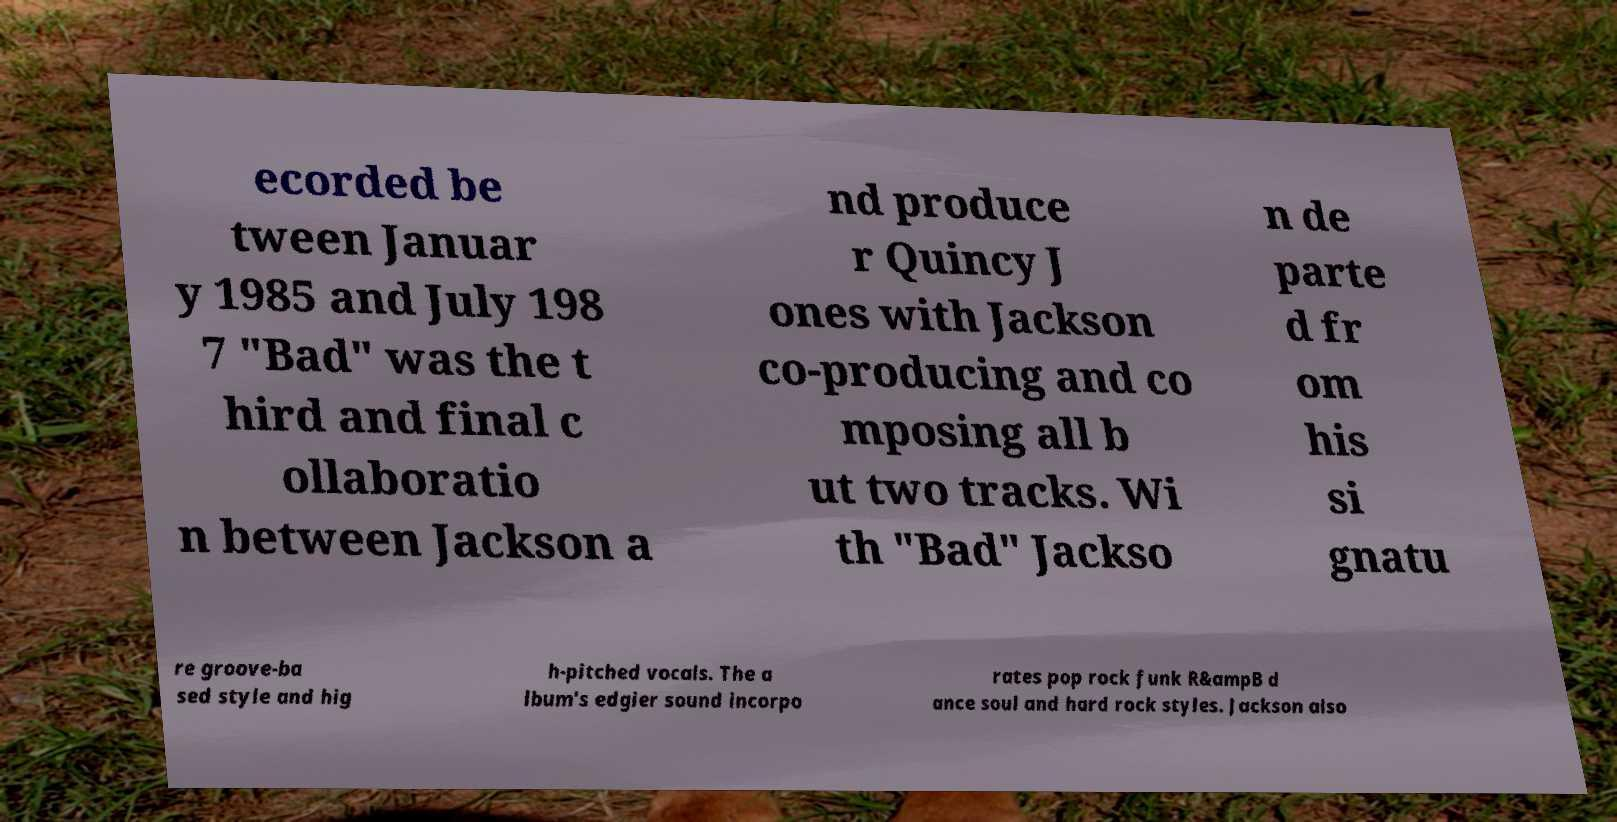Can you accurately transcribe the text from the provided image for me? ecorded be tween Januar y 1985 and July 198 7 "Bad" was the t hird and final c ollaboratio n between Jackson a nd produce r Quincy J ones with Jackson co-producing and co mposing all b ut two tracks. Wi th "Bad" Jackso n de parte d fr om his si gnatu re groove-ba sed style and hig h-pitched vocals. The a lbum's edgier sound incorpo rates pop rock funk R&ampB d ance soul and hard rock styles. Jackson also 